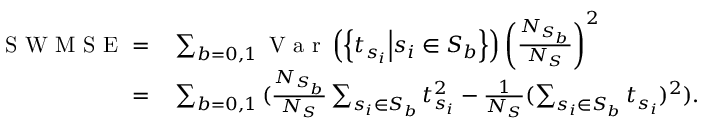Convert formula to latex. <formula><loc_0><loc_0><loc_500><loc_500>\begin{array} { r l } { S W M S E = } & \sum _ { b = 0 , 1 } { V a r \left ( \left \{ t _ { s _ { i } } | d l e | s _ { i } \in S _ { b } \right \} \right ) \left ( \frac { N _ { S _ { b } } } { N _ { S } } \right ) ^ { 2 } } } \\ { = } & \sum _ { b = 0 , 1 } { ( \frac { N _ { S _ { b } } } { N _ { S } } \sum _ { s _ { i } \in S _ { b } } t _ { s _ { i } } ^ { 2 } - \frac { 1 } { N _ { S } } ( \sum _ { s _ { i } \in S _ { b } } t _ { s _ { i } } ) ^ { 2 } ) } . } \end{array}</formula> 